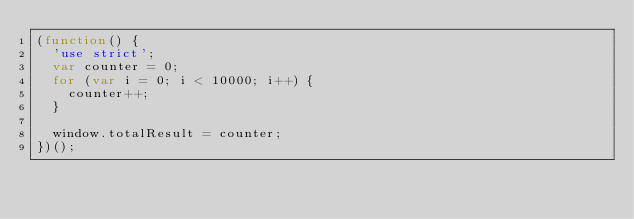<code> <loc_0><loc_0><loc_500><loc_500><_JavaScript_>(function() {
  'use strict';
  var counter = 0;
  for (var i = 0; i < 10000; i++) {
    counter++;
  }

  window.totalResult = counter;
})();
</code> 